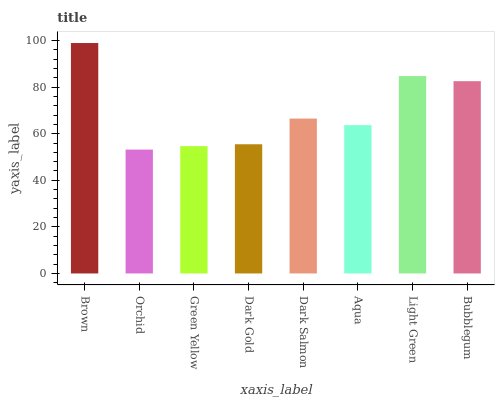Is Orchid the minimum?
Answer yes or no. Yes. Is Brown the maximum?
Answer yes or no. Yes. Is Green Yellow the minimum?
Answer yes or no. No. Is Green Yellow the maximum?
Answer yes or no. No. Is Green Yellow greater than Orchid?
Answer yes or no. Yes. Is Orchid less than Green Yellow?
Answer yes or no. Yes. Is Orchid greater than Green Yellow?
Answer yes or no. No. Is Green Yellow less than Orchid?
Answer yes or no. No. Is Dark Salmon the high median?
Answer yes or no. Yes. Is Aqua the low median?
Answer yes or no. Yes. Is Bubblegum the high median?
Answer yes or no. No. Is Bubblegum the low median?
Answer yes or no. No. 